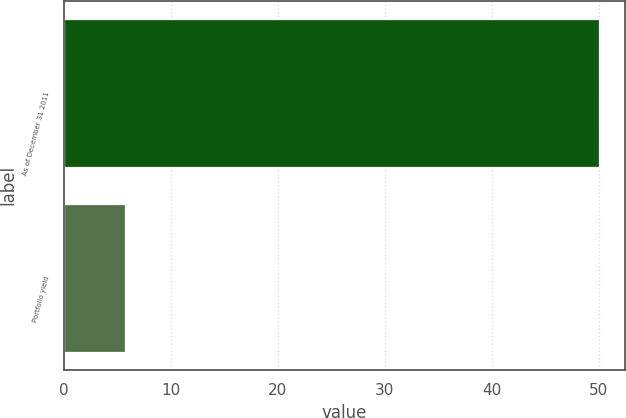<chart> <loc_0><loc_0><loc_500><loc_500><bar_chart><fcel>As of December 31 2011<fcel>Portfolio yield<nl><fcel>50<fcel>5.68<nl></chart> 